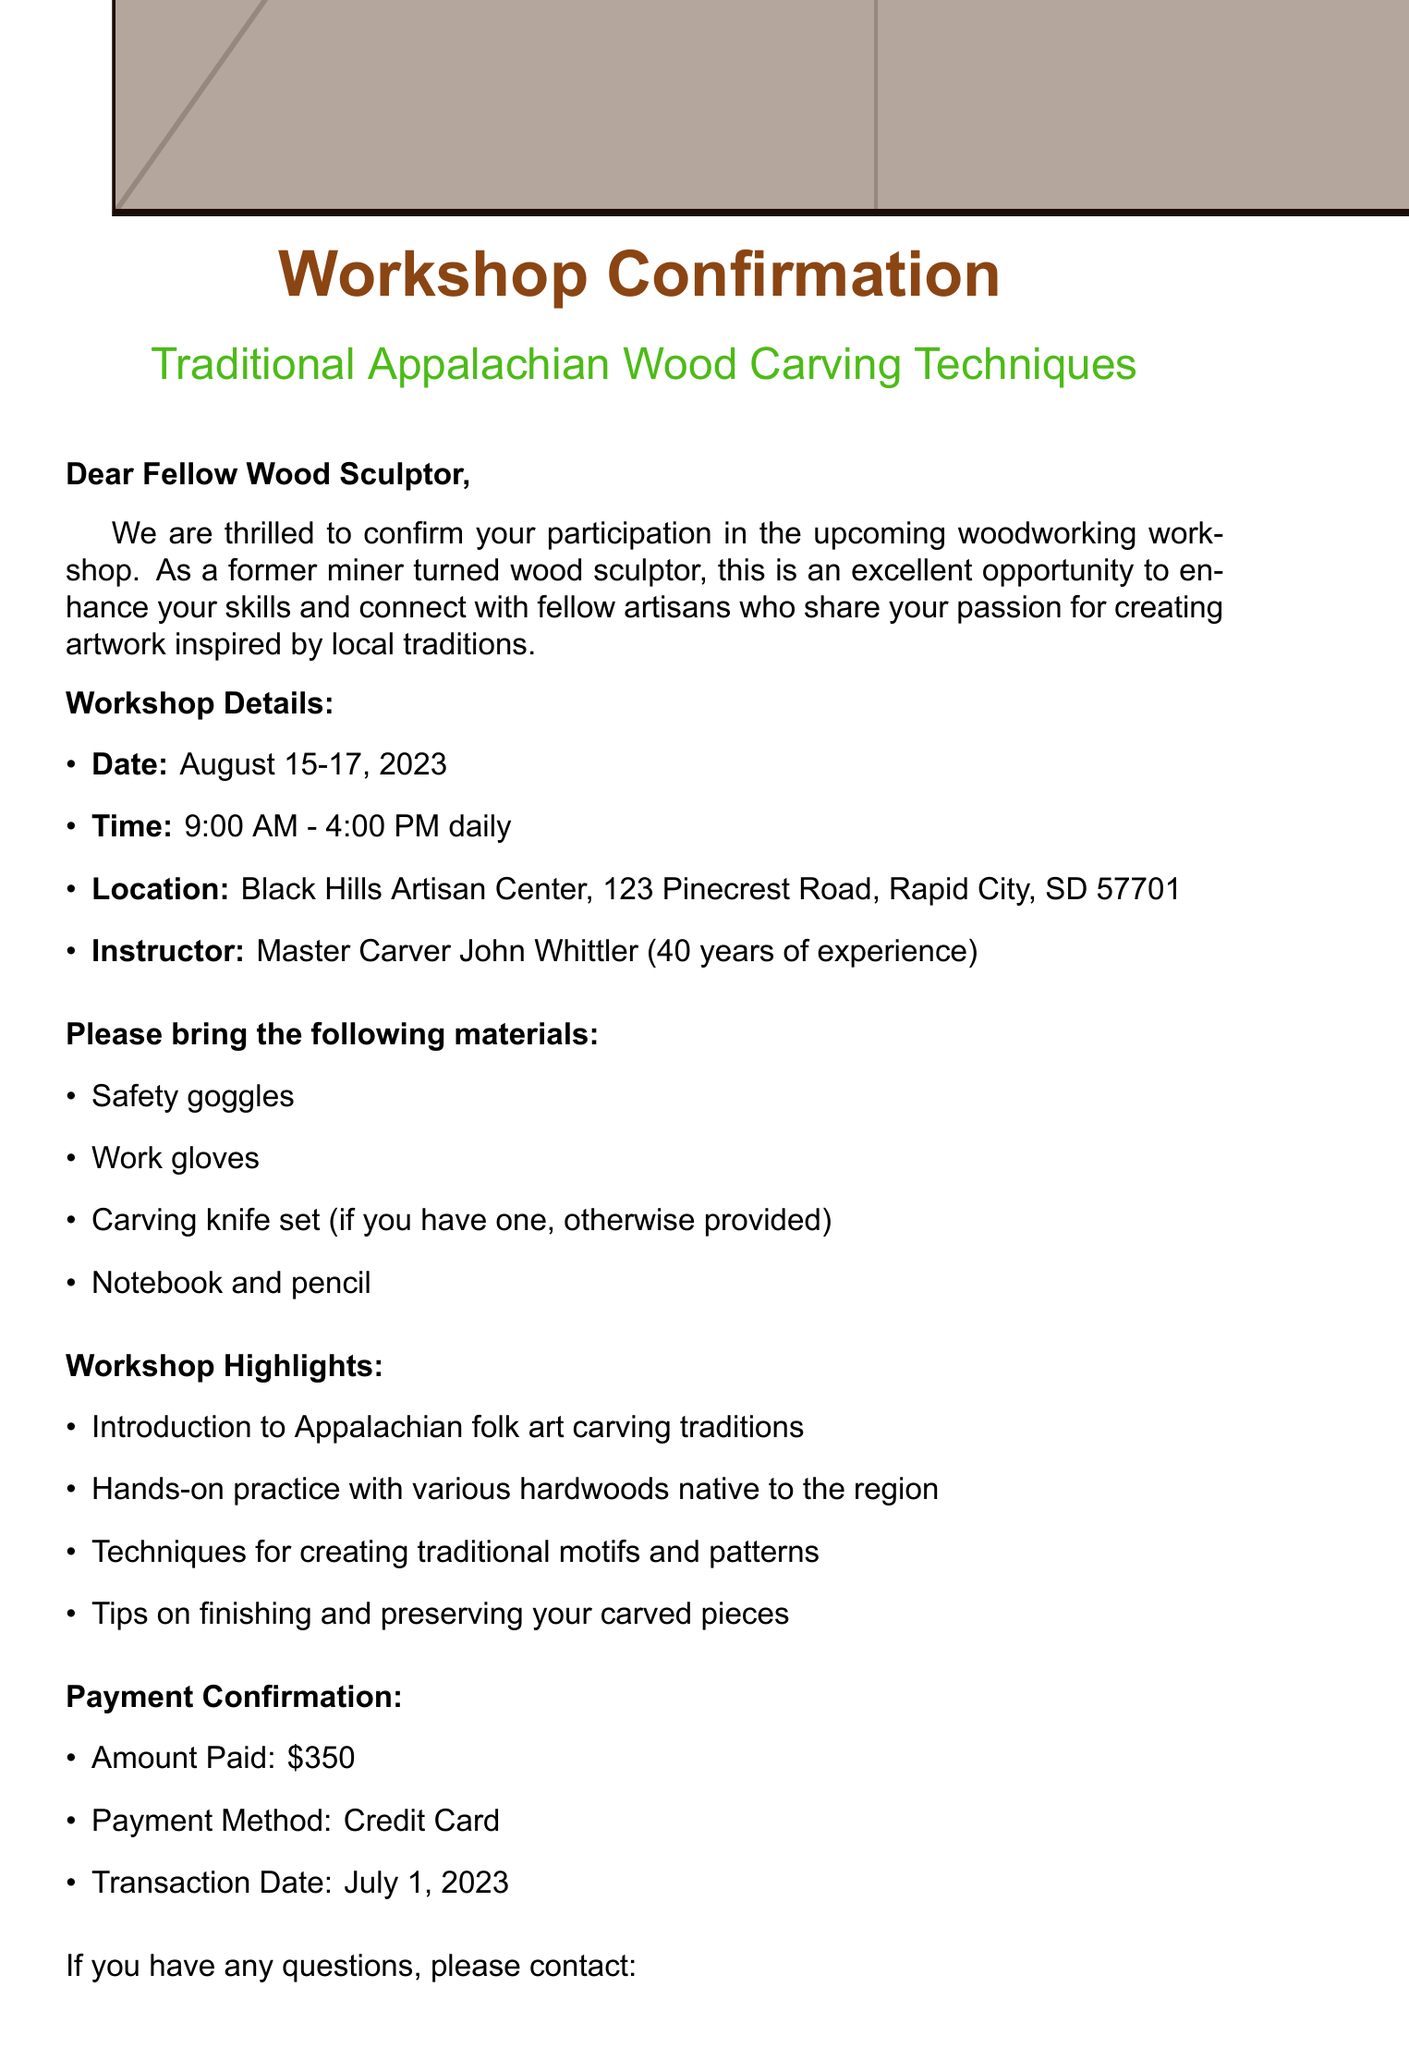What are the workshop dates? The workshop takes place from August 15 to August 17, 2023.
Answer: August 15-17, 2023 Who is the instructor of the workshop? The workshop will be led by Master Carver John Whittler.
Answer: Master Carver John Whittler What is the payment amount confirmed? The amount paid for the workshop is mentioned in the document.
Answer: $350 What time does the workshop start each day? The starting time for the workshop is specified in the schedule.
Answer: 9:00 AM What materials are participants required to bring? The document lists specific items participants should bring to the workshop.
Answer: Safety goggles, Work gloves, Carving knife set, Notebook and pencil What is the main focus of the workshop? The workshop is centered around learning specific traditional carving techniques.
Answer: Traditional Appalachian Wood Carving Techniques What is the location of the workshop? The venue is clearly stated in the document as the Black Hills Artisan Center.
Answer: Black Hills Artisan Center How can participants contact the organizer? Contact details for the organizer, including phone and email, are provided.
Answer: Sarah Craftsman, (605) 555-1234, info@blackhillsartisan.com What unique background does the instructor have? The document describes the instructor's level of experience in traditional wood carving.
Answer: 40 years of experience 